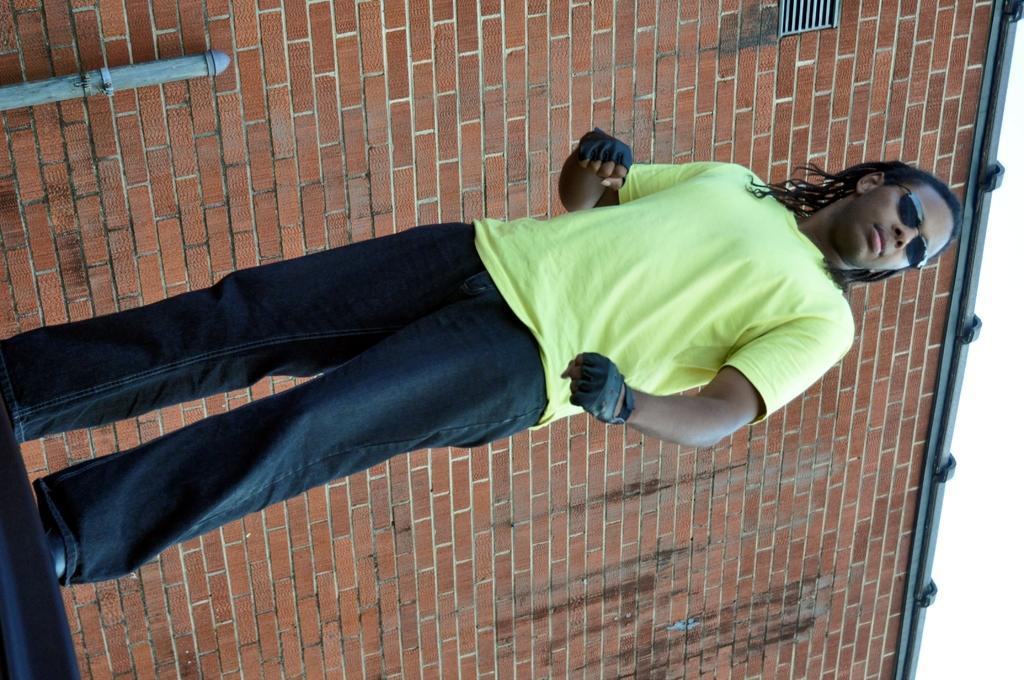Describe this image in one or two sentences. In the picture we can see a man standing and behind him we can see the wall. 